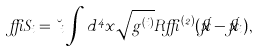<formula> <loc_0><loc_0><loc_500><loc_500>\delta S _ { i } = \lambda _ { i } \int d ^ { 4 } x \sqrt { g ^ { ( i ) } } R \delta ^ { ( 2 ) } ( \vec { x } - \vec { x } _ { i } ) ,</formula> 